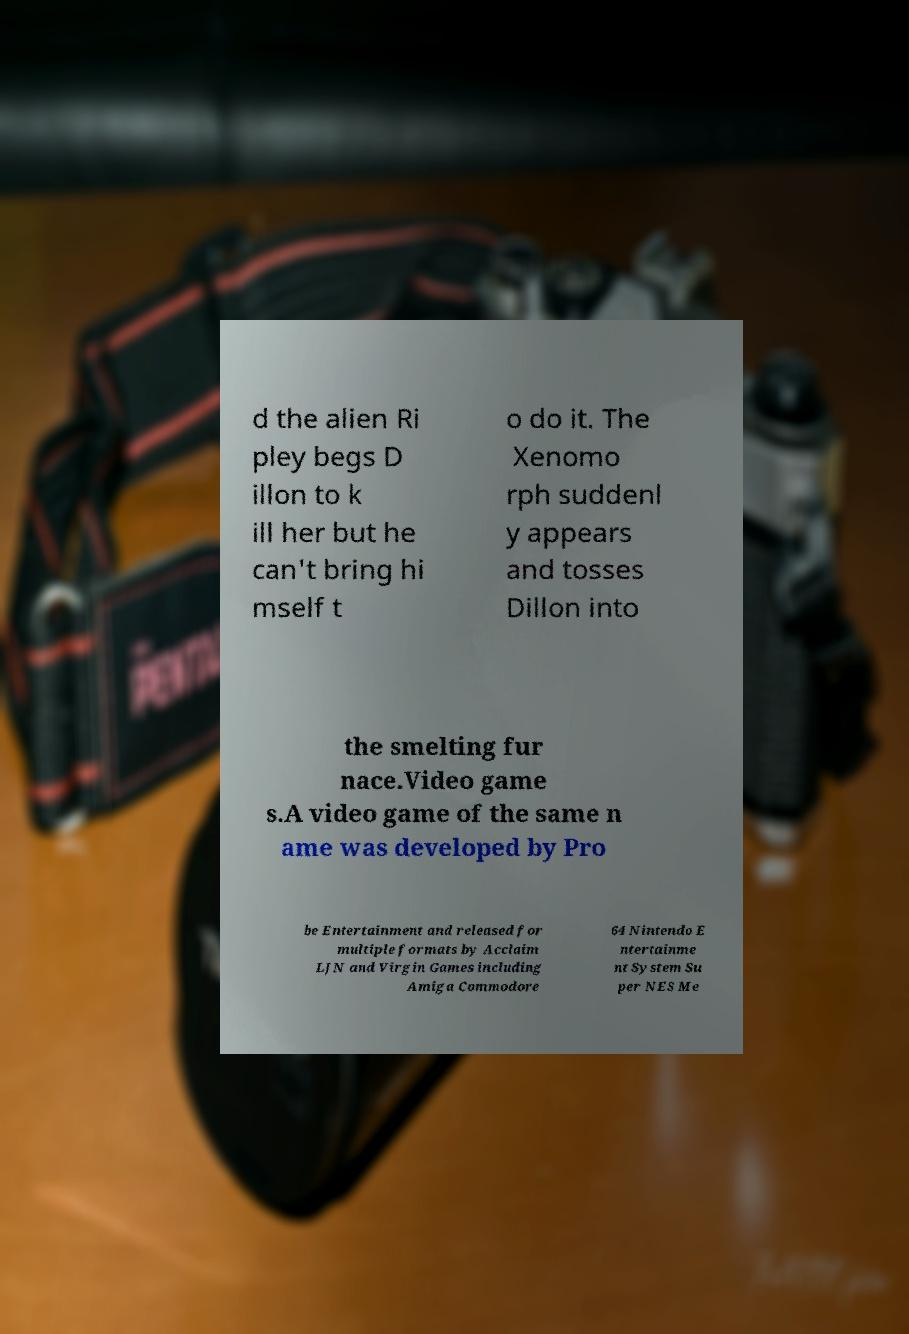For documentation purposes, I need the text within this image transcribed. Could you provide that? d the alien Ri pley begs D illon to k ill her but he can't bring hi mself t o do it. The Xenomo rph suddenl y appears and tosses Dillon into the smelting fur nace.Video game s.A video game of the same n ame was developed by Pro be Entertainment and released for multiple formats by Acclaim LJN and Virgin Games including Amiga Commodore 64 Nintendo E ntertainme nt System Su per NES Me 